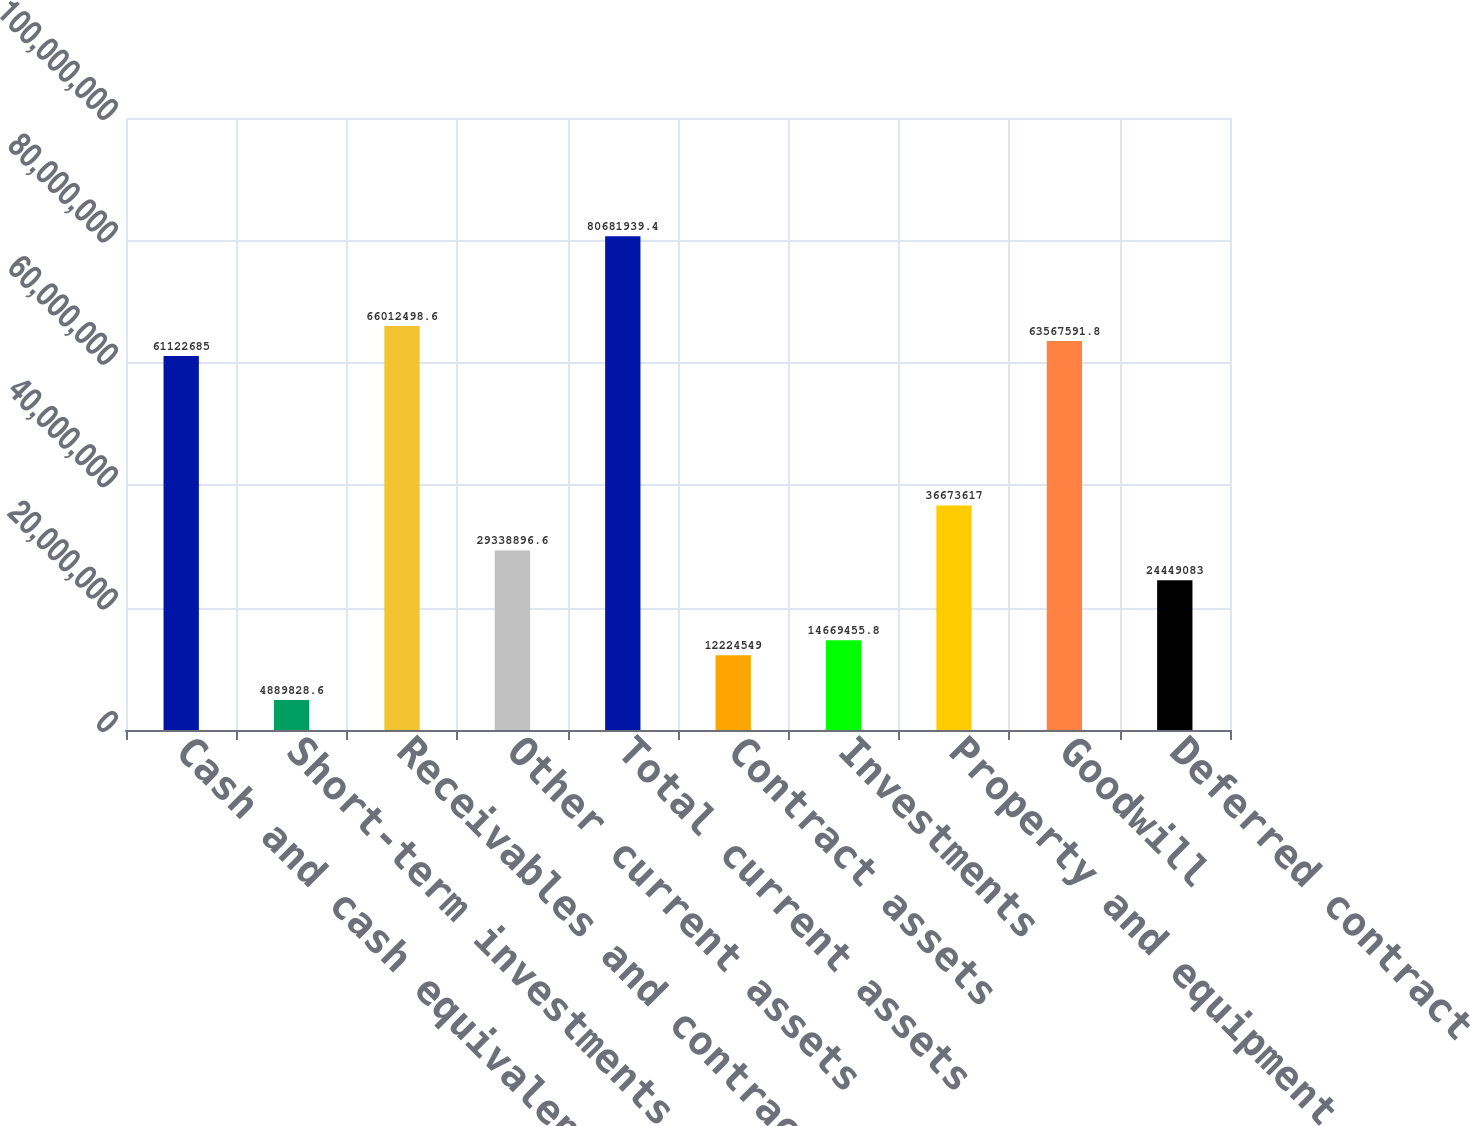Convert chart to OTSL. <chart><loc_0><loc_0><loc_500><loc_500><bar_chart><fcel>Cash and cash equivalents<fcel>Short-term investments<fcel>Receivables and contract<fcel>Other current assets<fcel>Total current assets<fcel>Contract assets<fcel>Investments<fcel>Property and equipment net<fcel>Goodwill<fcel>Deferred contract costs<nl><fcel>6.11227e+07<fcel>4.88983e+06<fcel>6.60125e+07<fcel>2.93389e+07<fcel>8.06819e+07<fcel>1.22245e+07<fcel>1.46695e+07<fcel>3.66736e+07<fcel>6.35676e+07<fcel>2.44491e+07<nl></chart> 